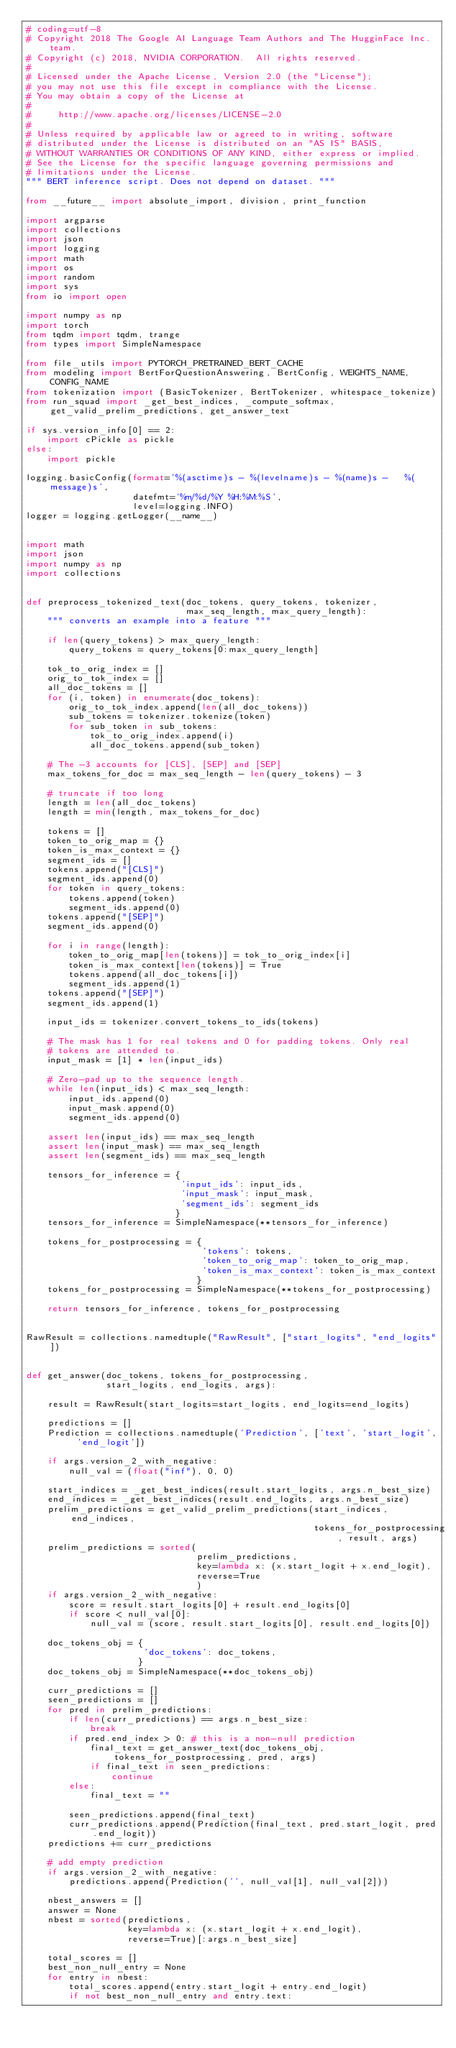<code> <loc_0><loc_0><loc_500><loc_500><_Python_># coding=utf-8
# Copyright 2018 The Google AI Language Team Authors and The HugginFace Inc. team.
# Copyright (c) 2018, NVIDIA CORPORATION.  All rights reserved.
#
# Licensed under the Apache License, Version 2.0 (the "License");
# you may not use this file except in compliance with the License.
# You may obtain a copy of the License at
#
#     http://www.apache.org/licenses/LICENSE-2.0
#
# Unless required by applicable law or agreed to in writing, software
# distributed under the License is distributed on an "AS IS" BASIS,
# WITHOUT WARRANTIES OR CONDITIONS OF ANY KIND, either express or implied.
# See the License for the specific language governing permissions and
# limitations under the License. 
""" BERT inference script. Does not depend on dataset. """

from __future__ import absolute_import, division, print_function

import argparse
import collections
import json
import logging
import math
import os
import random
import sys
from io import open

import numpy as np
import torch
from tqdm import tqdm, trange
from types import SimpleNamespace

from file_utils import PYTORCH_PRETRAINED_BERT_CACHE
from modeling import BertForQuestionAnswering, BertConfig, WEIGHTS_NAME, CONFIG_NAME
from tokenization import (BasicTokenizer, BertTokenizer, whitespace_tokenize)
from run_squad import _get_best_indices, _compute_softmax, get_valid_prelim_predictions, get_answer_text

if sys.version_info[0] == 2:
    import cPickle as pickle
else:
    import pickle

logging.basicConfig(format='%(asctime)s - %(levelname)s - %(name)s -   %(message)s',
                    datefmt='%m/%d/%Y %H:%M:%S',
                    level=logging.INFO)
logger = logging.getLogger(__name__)


import math
import json
import numpy as np
import collections


def preprocess_tokenized_text(doc_tokens, query_tokens, tokenizer, 
                              max_seq_length, max_query_length):
    """ converts an example into a feature """
    
    if len(query_tokens) > max_query_length:
        query_tokens = query_tokens[0:max_query_length]
    
    tok_to_orig_index = []
    orig_to_tok_index = []
    all_doc_tokens = []
    for (i, token) in enumerate(doc_tokens):
        orig_to_tok_index.append(len(all_doc_tokens))
        sub_tokens = tokenizer.tokenize(token)
        for sub_token in sub_tokens:
            tok_to_orig_index.append(i)
            all_doc_tokens.append(sub_token)
    
    # The -3 accounts for [CLS], [SEP] and [SEP]
    max_tokens_for_doc = max_seq_length - len(query_tokens) - 3
    
    # truncate if too long
    length = len(all_doc_tokens)
    length = min(length, max_tokens_for_doc)
    
    tokens = []
    token_to_orig_map = {}
    token_is_max_context = {}
    segment_ids = []
    tokens.append("[CLS]")
    segment_ids.append(0)
    for token in query_tokens:
        tokens.append(token)
        segment_ids.append(0)
    tokens.append("[SEP]")
    segment_ids.append(0)
    
    for i in range(length):
        token_to_orig_map[len(tokens)] = tok_to_orig_index[i]
        token_is_max_context[len(tokens)] = True
        tokens.append(all_doc_tokens[i])
        segment_ids.append(1)
    tokens.append("[SEP]")
    segment_ids.append(1)
    
    input_ids = tokenizer.convert_tokens_to_ids(tokens)
    
    # The mask has 1 for real tokens and 0 for padding tokens. Only real
    # tokens are attended to.
    input_mask = [1] * len(input_ids)
    
    # Zero-pad up to the sequence length.
    while len(input_ids) < max_seq_length:
        input_ids.append(0)
        input_mask.append(0)
        segment_ids.append(0)
    
    assert len(input_ids) == max_seq_length
    assert len(input_mask) == max_seq_length
    assert len(segment_ids) == max_seq_length
    
    tensors_for_inference = {
                             'input_ids': input_ids, 
                             'input_mask': input_mask, 
                             'segment_ids': segment_ids
                            }
    tensors_for_inference = SimpleNamespace(**tensors_for_inference)
    
    tokens_for_postprocessing = {
                                 'tokens': tokens,
                                 'token_to_orig_map': token_to_orig_map,
                                 'token_is_max_context': token_is_max_context
                                }
    tokens_for_postprocessing = SimpleNamespace(**tokens_for_postprocessing)
    
    return tensors_for_inference, tokens_for_postprocessing


RawResult = collections.namedtuple("RawResult", ["start_logits", "end_logits"])


def get_answer(doc_tokens, tokens_for_postprocessing, 
               start_logits, end_logits, args):
    
    result = RawResult(start_logits=start_logits, end_logits=end_logits)
    
    predictions = []
    Prediction = collections.namedtuple('Prediction', ['text', 'start_logit', 'end_logit'])
    
    if args.version_2_with_negative:
        null_val = (float("inf"), 0, 0)
    
    start_indices = _get_best_indices(result.start_logits, args.n_best_size)
    end_indices = _get_best_indices(result.end_logits, args.n_best_size)
    prelim_predictions = get_valid_prelim_predictions(start_indices, end_indices, 
                                                      tokens_for_postprocessing, result, args)
    prelim_predictions = sorted(
                                prelim_predictions,
                                key=lambda x: (x.start_logit + x.end_logit),
                                reverse=True
                                )
    if args.version_2_with_negative:
        score = result.start_logits[0] + result.end_logits[0]
        if score < null_val[0]:
            null_val = (score, result.start_logits[0], result.end_logits[0])
    
    doc_tokens_obj = {
                      'doc_tokens': doc_tokens, 
                     }
    doc_tokens_obj = SimpleNamespace(**doc_tokens_obj)

    curr_predictions = []
    seen_predictions = []
    for pred in prelim_predictions:
        if len(curr_predictions) == args.n_best_size:
            break
        if pred.end_index > 0: # this is a non-null prediction
            final_text = get_answer_text(doc_tokens_obj, tokens_for_postprocessing, pred, args)
            if final_text in seen_predictions:
                continue
        else:
            final_text = ""
        
        seen_predictions.append(final_text)
        curr_predictions.append(Prediction(final_text, pred.start_logit, pred.end_logit))
    predictions += curr_predictions
    
    # add empty prediction
    if args.version_2_with_negative:
        predictions.append(Prediction('', null_val[1], null_val[2]))
    
    nbest_answers = []
    answer = None
    nbest = sorted(predictions,
                   key=lambda x: (x.start_logit + x.end_logit),
                   reverse=True)[:args.n_best_size]
    
    total_scores = []
    best_non_null_entry = None
    for entry in nbest:
        total_scores.append(entry.start_logit + entry.end_logit)
        if not best_non_null_entry and entry.text:</code> 